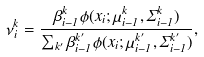Convert formula to latex. <formula><loc_0><loc_0><loc_500><loc_500>\nu ^ { k } _ { i } = \frac { \beta _ { i - 1 } ^ { k } \phi ( x _ { i } ; \mu _ { i - 1 } ^ { k } , \Sigma _ { i - 1 } ^ { k } ) } { \sum _ { k ^ { \prime } } \beta _ { i - 1 } ^ { k ^ { \prime } } \phi ( x _ { i } ; \mu _ { i - 1 } ^ { k ^ { \prime } } , \Sigma _ { i - 1 } ^ { k ^ { \prime } } ) } ,</formula> 